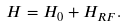Convert formula to latex. <formula><loc_0><loc_0><loc_500><loc_500>H = H _ { 0 } + H _ { R F } .</formula> 